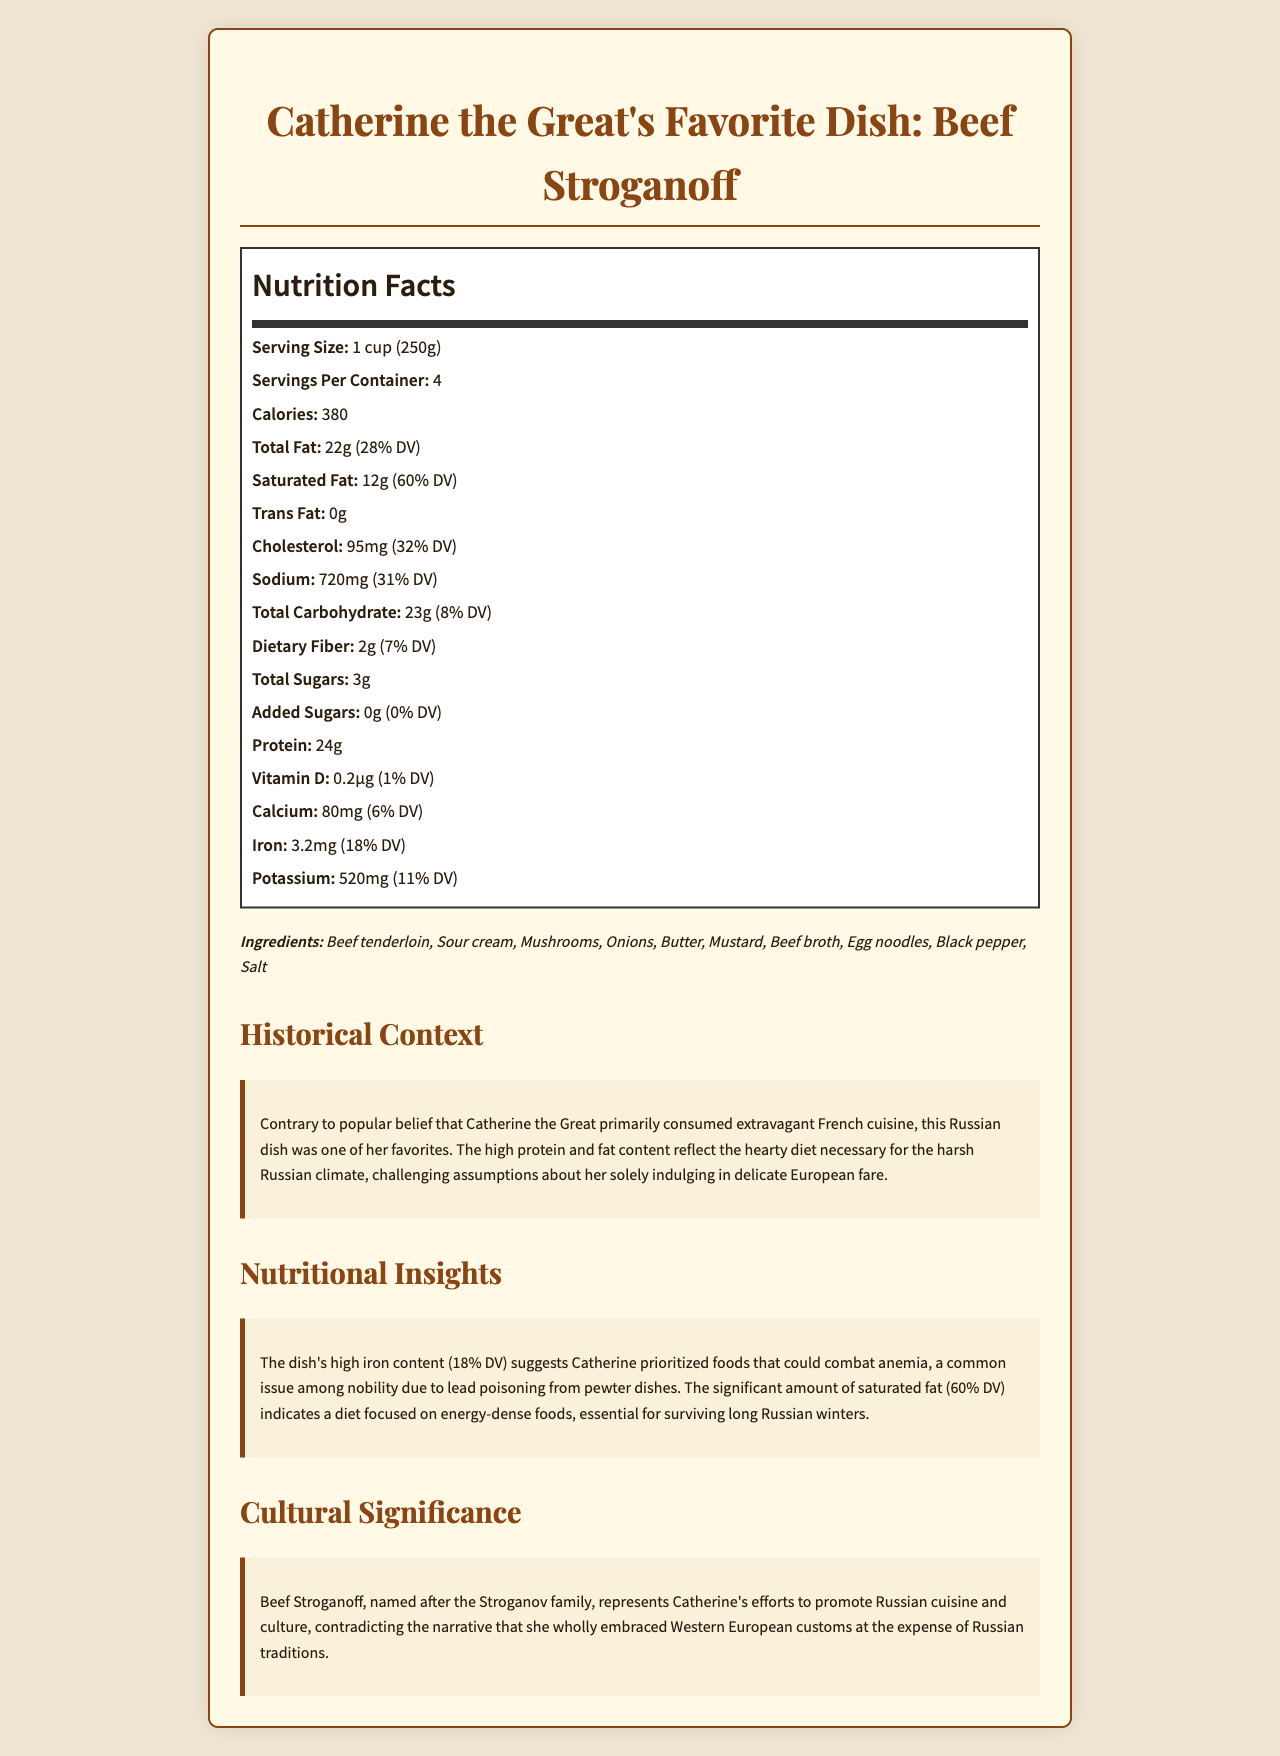what is the serving size for Catherine the Great's Beef Stroganoff? The serving size is clearly mentioned in the Nutrition Facts section as "1 cup (250g)".
Answer: 1 cup (250g) How many servings are there per container? The Nutrition Facts label specifies that there are 4 servings per container.
Answer: 4 How many grams of total fat are in one serving? Under the Total Fat section in the Nutrition Facts, it is listed that there are 22 grams of fat per serving.
Answer: 22 grams What percent of the daily value is the saturated fat in one serving? The Nutrition Facts label indicates that the saturated fat content is 60% of the daily value.
Answer: 60% What is the main source of protein in the dish? The ingredient list includes beef tenderloin, which is a primary source of protein for Beef Stroganoff.
Answer: Beef tenderloin How much sodium does each serving contain? According to the Nutrition Facts, the sodium content per serving is 720 milligrams.
Answer: 720 milligrams What is the primary historical context provided for Catherine the Great's diet? The historical context section mentions that Beef Stroganoff, a traditional Russian dish, was favored by Catherine the Great to meet the dietary demands of the harsh Russian climate.
Answer: Contrary to popular belief, Catherine the Great consumed hearty Russian dishes, such as Beef Stroganoff, to combat the harsh Russian climate. Which of the following ingredients are found in Catherine the Great's Beef Stroganoff? A. Parmesan Cheese B. Tomatoes C. Sour Cream The list of ingredients includes Sour Cream but not Parmesan Cheese or Tomatoes.
Answer: C. Sour Cream What percent of daily value for iron does each serving of Beef Stroganoff provide? A. 6% B. 11% C. 18% D. 32% The Nutrition Facts label specifies that each serving contains 18% of the daily value for iron.
Answer: C. 18% Does the dish contain any trans fat? The Nutrition Facts section clearly states that the trans fat content is 0 grams.
Answer: No Summarize the main idea of the document. The document includes a detailed Nutrition Facts label, a list of ingredients, and sections on historical context, nutritional insights, and cultural significance, challenging assumptions about Catherine the Great's diet.
Answer: The document provides the nutritional information for Catherine the Great's favorite dish, Beef Stroganoff, highlighting its historical, nutritional, and cultural significance. What is the reason for the high iron content in the dish according to the document? The nutritional insights section mentions the high iron content to counteract anemia caused by lead poisoning from pewter dishes.
Answer: It suggests Catherine the Great prioritized foods that could combat anemia, a common issue among the nobility due to lead poisoning from pewter dishes. What percentage of the daily value for calcium is provided by one serving of the dish? The Nutrition Facts section lists that each serving provides 6% of the daily value for calcium.
Answer: 6% Are egg noodles an ingredient in Catherine the Great's Beef Stroganoff? The ingredient list mentions egg noodles.
Answer: Yes Does the document specify if Catherine the Great completely abandoned Russian traditions? The cultural significance section mentions that Beef Stroganoff represents her efforts to promote Russian cuisine, contradicting the narrative that she wholly embraced Western European customs at the expense of Russian traditions.
Answer: No Based on the visual information in the document, which cultural narrative does the dish of Beef Stroganoff support regarding Catherine the Great? The cultural significance section states that Beef Stroganoff represents Catherine's efforts to promote Russian cuisine, thereby supporting the cultural narrative of her promoting Russian traditions.
Answer: It supports the narrative that Catherine the Great promoted Russian cuisine and culture. 